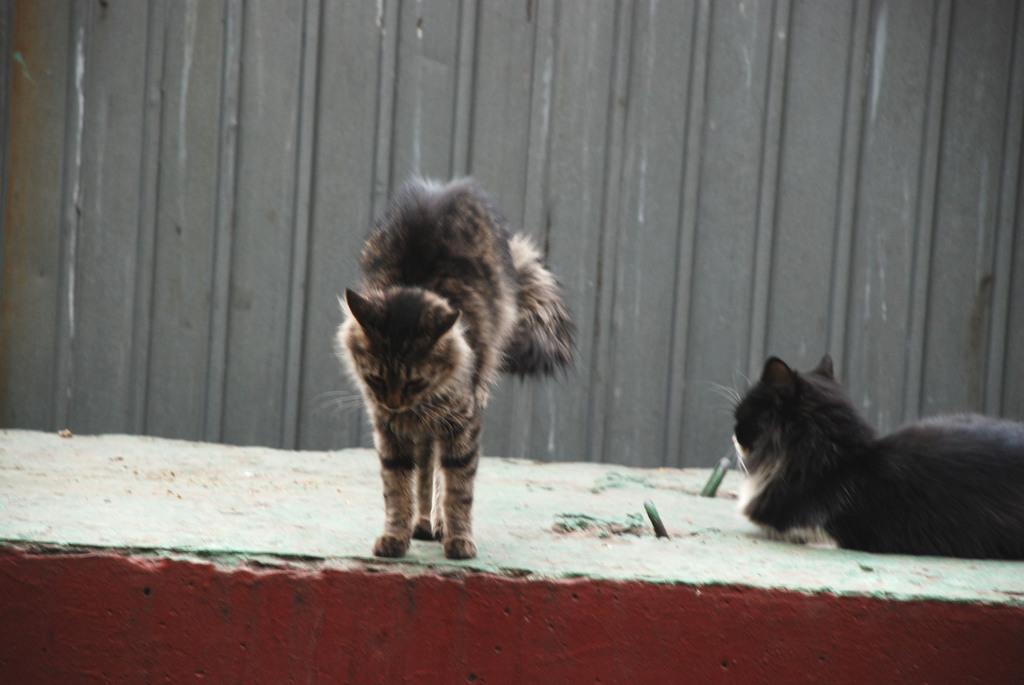In one or two sentences, can you explain what this image depicts? There is a cat in the foreground area of the image and another cat on the right side, it seems like a metal sheet in the background area. 